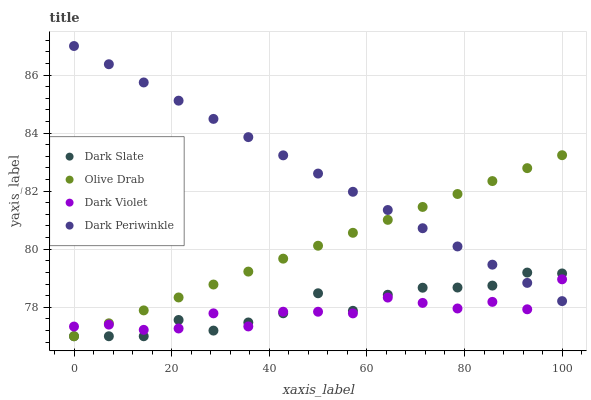Does Dark Violet have the minimum area under the curve?
Answer yes or no. Yes. Does Dark Periwinkle have the maximum area under the curve?
Answer yes or no. Yes. Does Olive Drab have the minimum area under the curve?
Answer yes or no. No. Does Olive Drab have the maximum area under the curve?
Answer yes or no. No. Is Dark Periwinkle the smoothest?
Answer yes or no. Yes. Is Dark Violet the roughest?
Answer yes or no. Yes. Is Olive Drab the smoothest?
Answer yes or no. No. Is Olive Drab the roughest?
Answer yes or no. No. Does Dark Slate have the lowest value?
Answer yes or no. Yes. Does Dark Violet have the lowest value?
Answer yes or no. No. Does Dark Periwinkle have the highest value?
Answer yes or no. Yes. Does Olive Drab have the highest value?
Answer yes or no. No. Does Olive Drab intersect Dark Violet?
Answer yes or no. Yes. Is Olive Drab less than Dark Violet?
Answer yes or no. No. Is Olive Drab greater than Dark Violet?
Answer yes or no. No. 